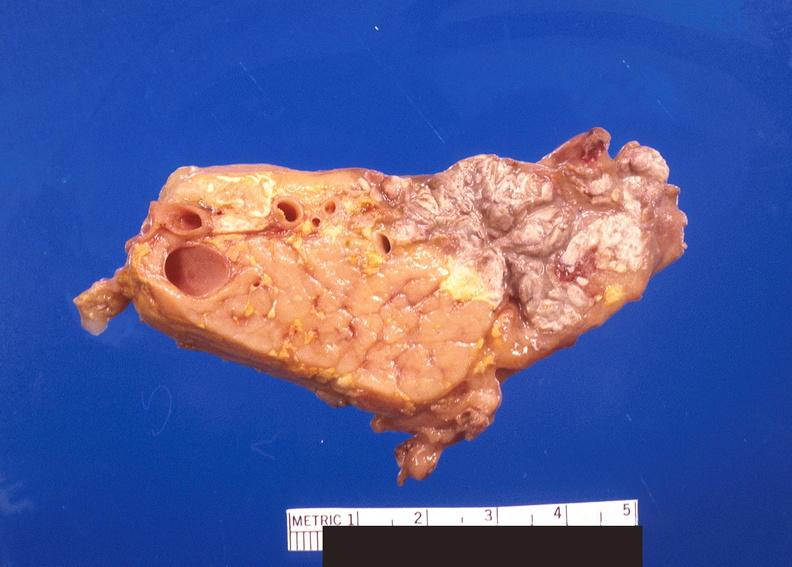does metastatic pancreas carcinoma show pancreatic fat necrosis?
Answer the question using a single word or phrase. No 